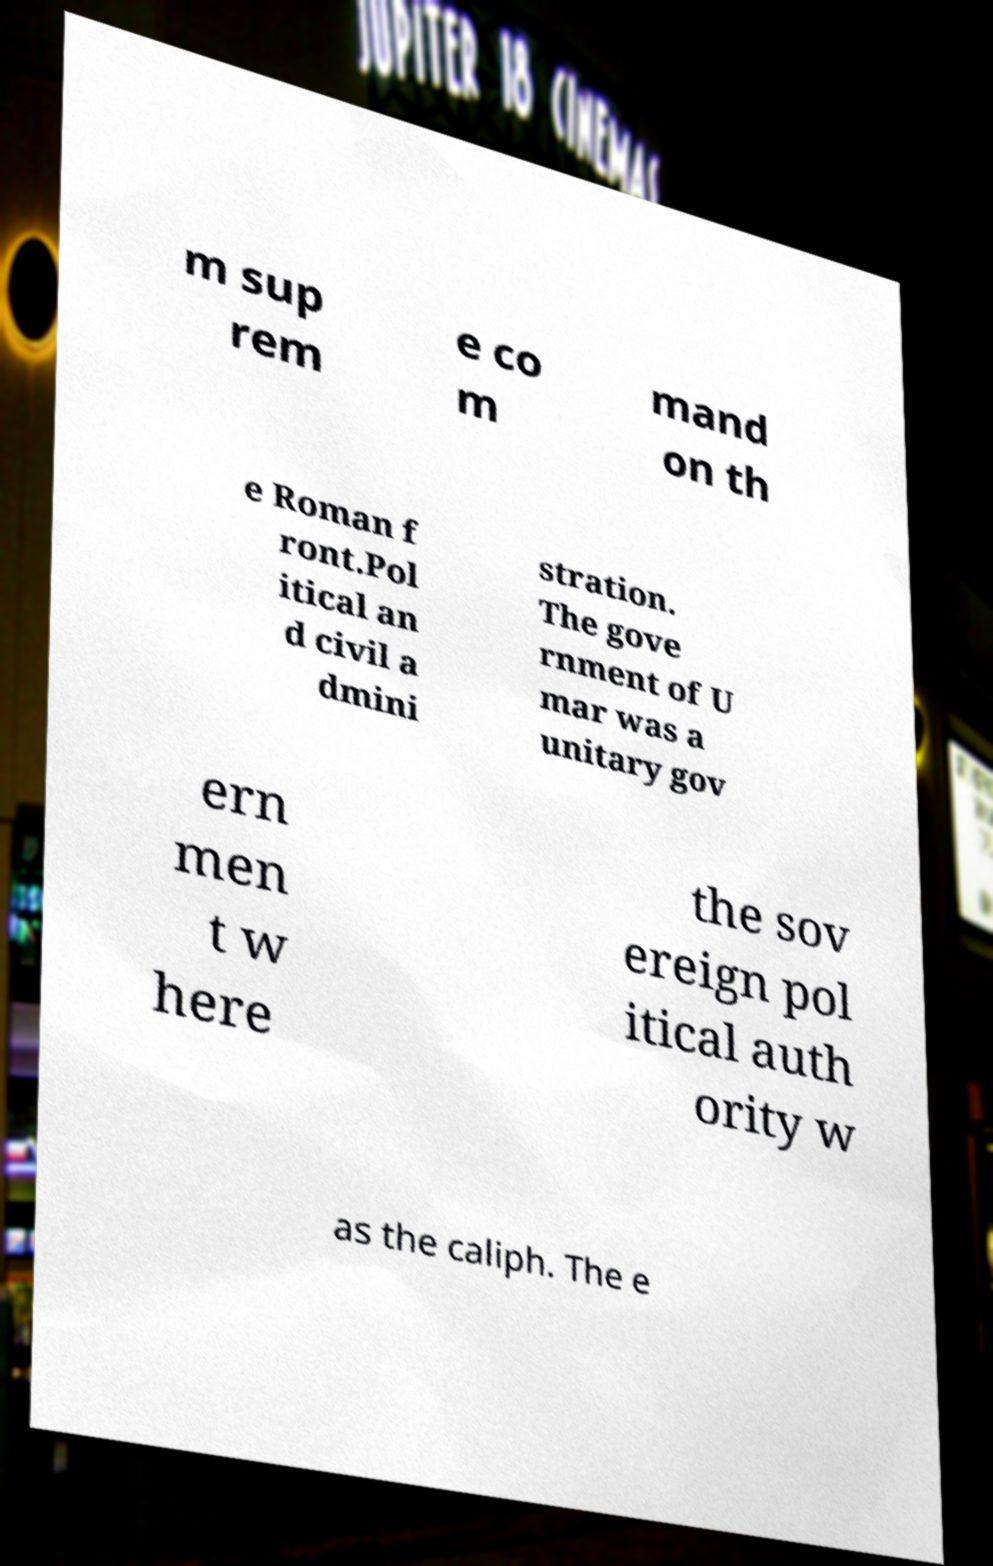I need the written content from this picture converted into text. Can you do that? m sup rem e co m mand on th e Roman f ront.Pol itical an d civil a dmini stration. The gove rnment of U mar was a unitary gov ern men t w here the sov ereign pol itical auth ority w as the caliph. The e 